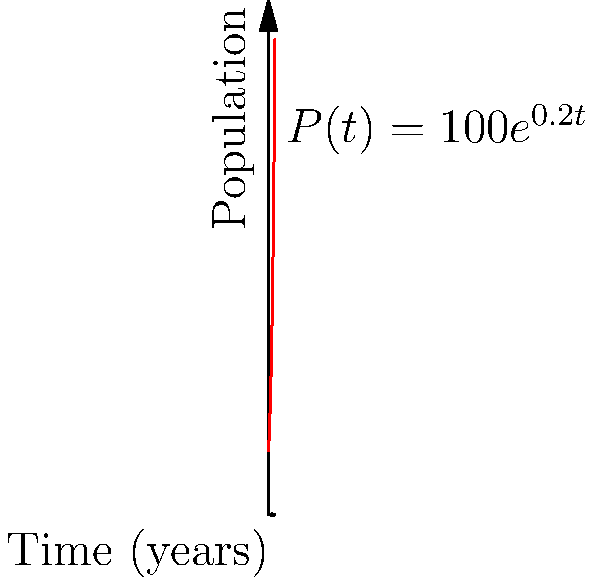The population growth of a species of pocket mouse (Chaetodipus formosus) in a protected habitat is modeled by the function $P(t) = 100e^{0.2t}$, where $P$ is the population size and $t$ is time in years. What is the instantaneous rate of change of the population after 5 years? To find the instantaneous rate of change of the population after 5 years, we need to follow these steps:

1) The instantaneous rate of change is given by the derivative of the function at the specified time.

2) The derivative of $P(t) = 100e^{0.2t}$ is:
   $P'(t) = 100 \cdot 0.2e^{0.2t} = 20e^{0.2t}$

3) To find the rate of change at 5 years, we evaluate $P'(5)$:
   $P'(5) = 20e^{0.2 \cdot 5} = 20e^1$

4) Calculate $e^1 \approx 2.71828$

5) Therefore, $P'(5) = 20 \cdot 2.71828 \approx 54.3656$

This means that after 5 years, the population is increasing at a rate of approximately 54.3656 pocket mice per year.
Answer: 54.3656 pocket mice per year 